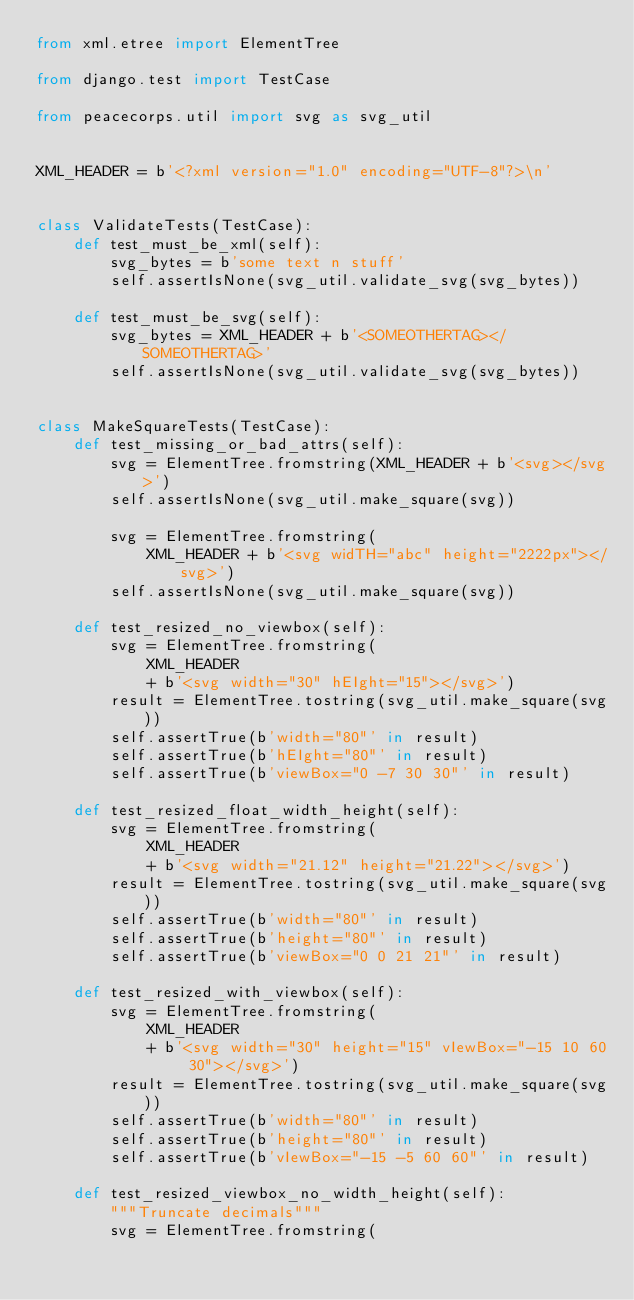<code> <loc_0><loc_0><loc_500><loc_500><_Python_>from xml.etree import ElementTree

from django.test import TestCase

from peacecorps.util import svg as svg_util


XML_HEADER = b'<?xml version="1.0" encoding="UTF-8"?>\n'


class ValidateTests(TestCase):
    def test_must_be_xml(self):
        svg_bytes = b'some text n stuff'
        self.assertIsNone(svg_util.validate_svg(svg_bytes))

    def test_must_be_svg(self):
        svg_bytes = XML_HEADER + b'<SOMEOTHERTAG></SOMEOTHERTAG>'
        self.assertIsNone(svg_util.validate_svg(svg_bytes))


class MakeSquareTests(TestCase):
    def test_missing_or_bad_attrs(self):
        svg = ElementTree.fromstring(XML_HEADER + b'<svg></svg>')
        self.assertIsNone(svg_util.make_square(svg))

        svg = ElementTree.fromstring(
            XML_HEADER + b'<svg widTH="abc" height="2222px"></svg>')
        self.assertIsNone(svg_util.make_square(svg))

    def test_resized_no_viewbox(self):
        svg = ElementTree.fromstring(
            XML_HEADER
            + b'<svg width="30" hEIght="15"></svg>')
        result = ElementTree.tostring(svg_util.make_square(svg))
        self.assertTrue(b'width="80"' in result)
        self.assertTrue(b'hEIght="80"' in result)
        self.assertTrue(b'viewBox="0 -7 30 30"' in result)

    def test_resized_float_width_height(self):
        svg = ElementTree.fromstring(
            XML_HEADER
            + b'<svg width="21.12" height="21.22"></svg>')
        result = ElementTree.tostring(svg_util.make_square(svg))
        self.assertTrue(b'width="80"' in result)
        self.assertTrue(b'height="80"' in result)
        self.assertTrue(b'viewBox="0 0 21 21"' in result)

    def test_resized_with_viewbox(self):
        svg = ElementTree.fromstring(
            XML_HEADER
            + b'<svg width="30" height="15" vIewBox="-15 10 60 30"></svg>')
        result = ElementTree.tostring(svg_util.make_square(svg))
        self.assertTrue(b'width="80"' in result)
        self.assertTrue(b'height="80"' in result)
        self.assertTrue(b'vIewBox="-15 -5 60 60"' in result)

    def test_resized_viewbox_no_width_height(self):
        """Truncate decimals"""
        svg = ElementTree.fromstring(</code> 